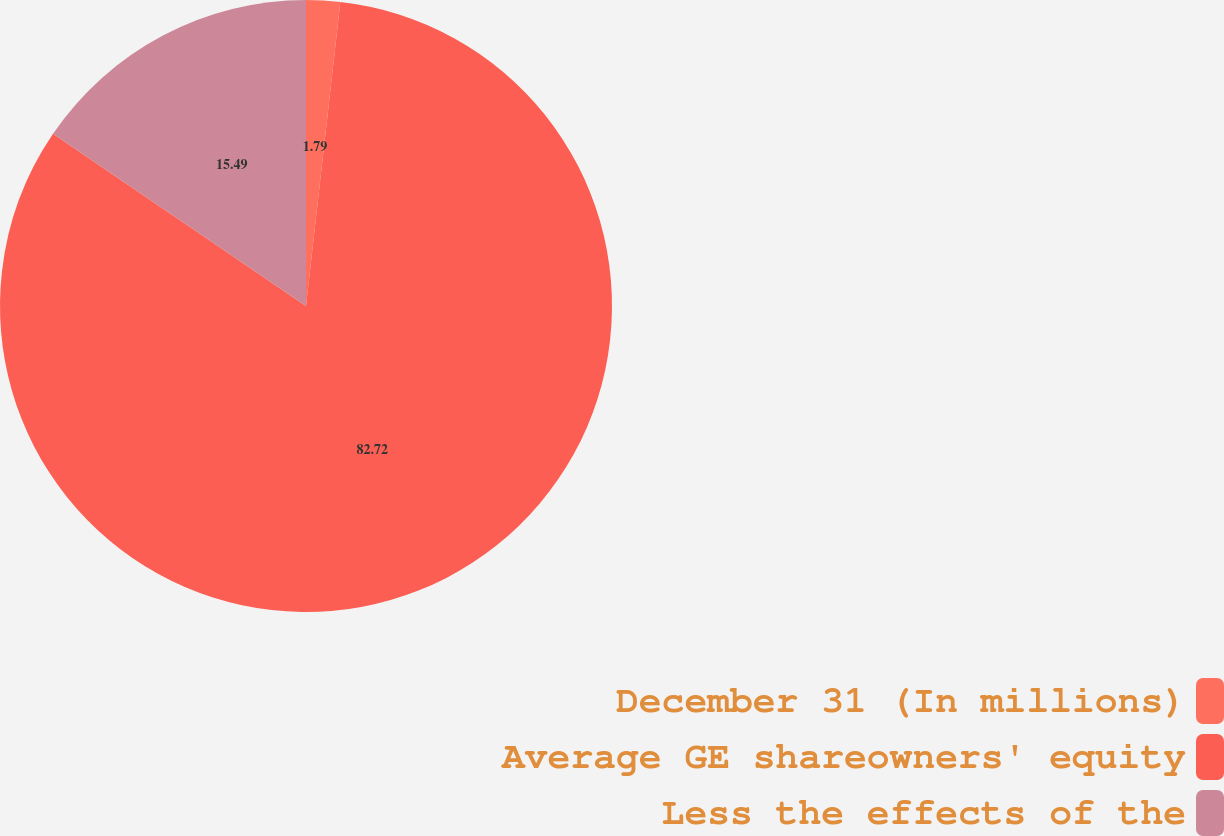Convert chart. <chart><loc_0><loc_0><loc_500><loc_500><pie_chart><fcel>December 31 (In millions)<fcel>Average GE shareowners' equity<fcel>Less the effects of the<nl><fcel>1.79%<fcel>82.73%<fcel>15.49%<nl></chart> 